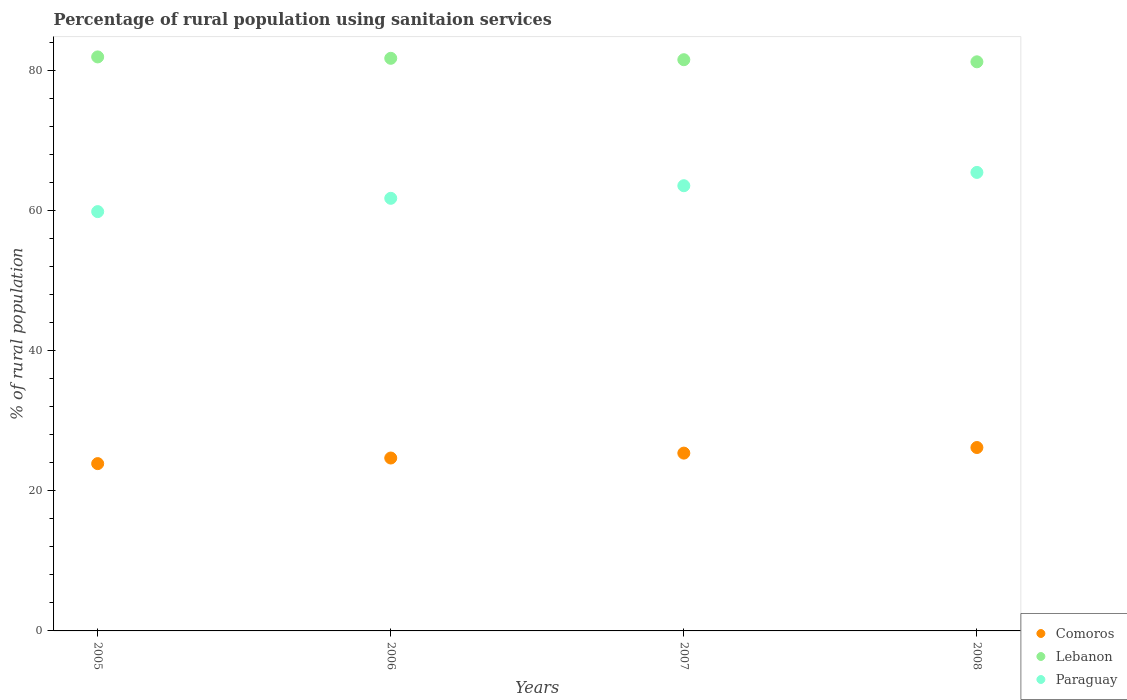How many different coloured dotlines are there?
Provide a succinct answer. 3. What is the percentage of rural population using sanitaion services in Paraguay in 2005?
Your answer should be very brief. 59.9. Across all years, what is the maximum percentage of rural population using sanitaion services in Comoros?
Your answer should be compact. 26.2. Across all years, what is the minimum percentage of rural population using sanitaion services in Comoros?
Provide a succinct answer. 23.9. In which year was the percentage of rural population using sanitaion services in Comoros maximum?
Your answer should be very brief. 2008. What is the total percentage of rural population using sanitaion services in Paraguay in the graph?
Keep it short and to the point. 250.8. What is the difference between the percentage of rural population using sanitaion services in Comoros in 2007 and that in 2008?
Offer a terse response. -0.8. What is the difference between the percentage of rural population using sanitaion services in Lebanon in 2006 and the percentage of rural population using sanitaion services in Paraguay in 2005?
Provide a succinct answer. 21.9. What is the average percentage of rural population using sanitaion services in Lebanon per year?
Provide a short and direct response. 81.67. In the year 2006, what is the difference between the percentage of rural population using sanitaion services in Lebanon and percentage of rural population using sanitaion services in Paraguay?
Your answer should be compact. 20. What is the ratio of the percentage of rural population using sanitaion services in Lebanon in 2006 to that in 2007?
Give a very brief answer. 1. Is the percentage of rural population using sanitaion services in Paraguay in 2006 less than that in 2008?
Offer a very short reply. Yes. What is the difference between the highest and the second highest percentage of rural population using sanitaion services in Lebanon?
Your response must be concise. 0.2. What is the difference between the highest and the lowest percentage of rural population using sanitaion services in Paraguay?
Ensure brevity in your answer.  5.6. In how many years, is the percentage of rural population using sanitaion services in Comoros greater than the average percentage of rural population using sanitaion services in Comoros taken over all years?
Ensure brevity in your answer.  2. Is the percentage of rural population using sanitaion services in Comoros strictly greater than the percentage of rural population using sanitaion services in Lebanon over the years?
Give a very brief answer. No. How many dotlines are there?
Give a very brief answer. 3. What is the difference between two consecutive major ticks on the Y-axis?
Offer a terse response. 20. Are the values on the major ticks of Y-axis written in scientific E-notation?
Offer a terse response. No. Does the graph contain any zero values?
Your response must be concise. No. Does the graph contain grids?
Make the answer very short. No. How are the legend labels stacked?
Your answer should be compact. Vertical. What is the title of the graph?
Ensure brevity in your answer.  Percentage of rural population using sanitaion services. What is the label or title of the X-axis?
Offer a terse response. Years. What is the label or title of the Y-axis?
Your response must be concise. % of rural population. What is the % of rural population in Comoros in 2005?
Your answer should be compact. 23.9. What is the % of rural population in Lebanon in 2005?
Offer a very short reply. 82. What is the % of rural population in Paraguay in 2005?
Provide a succinct answer. 59.9. What is the % of rural population in Comoros in 2006?
Provide a short and direct response. 24.7. What is the % of rural population of Lebanon in 2006?
Offer a very short reply. 81.8. What is the % of rural population of Paraguay in 2006?
Make the answer very short. 61.8. What is the % of rural population of Comoros in 2007?
Make the answer very short. 25.4. What is the % of rural population in Lebanon in 2007?
Your answer should be very brief. 81.6. What is the % of rural population of Paraguay in 2007?
Your answer should be compact. 63.6. What is the % of rural population in Comoros in 2008?
Your answer should be compact. 26.2. What is the % of rural population of Lebanon in 2008?
Offer a terse response. 81.3. What is the % of rural population in Paraguay in 2008?
Give a very brief answer. 65.5. Across all years, what is the maximum % of rural population in Comoros?
Ensure brevity in your answer.  26.2. Across all years, what is the maximum % of rural population of Lebanon?
Make the answer very short. 82. Across all years, what is the maximum % of rural population of Paraguay?
Make the answer very short. 65.5. Across all years, what is the minimum % of rural population of Comoros?
Offer a very short reply. 23.9. Across all years, what is the minimum % of rural population in Lebanon?
Give a very brief answer. 81.3. Across all years, what is the minimum % of rural population of Paraguay?
Offer a very short reply. 59.9. What is the total % of rural population of Comoros in the graph?
Make the answer very short. 100.2. What is the total % of rural population in Lebanon in the graph?
Your answer should be compact. 326.7. What is the total % of rural population in Paraguay in the graph?
Offer a terse response. 250.8. What is the difference between the % of rural population of Lebanon in 2005 and that in 2006?
Offer a terse response. 0.2. What is the difference between the % of rural population in Paraguay in 2005 and that in 2006?
Your answer should be compact. -1.9. What is the difference between the % of rural population in Comoros in 2005 and that in 2007?
Your answer should be very brief. -1.5. What is the difference between the % of rural population of Lebanon in 2005 and that in 2007?
Provide a short and direct response. 0.4. What is the difference between the % of rural population in Paraguay in 2005 and that in 2007?
Provide a short and direct response. -3.7. What is the difference between the % of rural population of Lebanon in 2005 and that in 2008?
Your answer should be compact. 0.7. What is the difference between the % of rural population of Comoros in 2006 and that in 2007?
Your answer should be compact. -0.7. What is the difference between the % of rural population of Comoros in 2006 and that in 2008?
Make the answer very short. -1.5. What is the difference between the % of rural population in Paraguay in 2006 and that in 2008?
Provide a succinct answer. -3.7. What is the difference between the % of rural population in Comoros in 2007 and that in 2008?
Provide a short and direct response. -0.8. What is the difference between the % of rural population in Comoros in 2005 and the % of rural population in Lebanon in 2006?
Offer a very short reply. -57.9. What is the difference between the % of rural population in Comoros in 2005 and the % of rural population in Paraguay in 2006?
Keep it short and to the point. -37.9. What is the difference between the % of rural population of Lebanon in 2005 and the % of rural population of Paraguay in 2006?
Your answer should be compact. 20.2. What is the difference between the % of rural population in Comoros in 2005 and the % of rural population in Lebanon in 2007?
Provide a succinct answer. -57.7. What is the difference between the % of rural population of Comoros in 2005 and the % of rural population of Paraguay in 2007?
Provide a short and direct response. -39.7. What is the difference between the % of rural population in Comoros in 2005 and the % of rural population in Lebanon in 2008?
Your answer should be very brief. -57.4. What is the difference between the % of rural population in Comoros in 2005 and the % of rural population in Paraguay in 2008?
Make the answer very short. -41.6. What is the difference between the % of rural population in Comoros in 2006 and the % of rural population in Lebanon in 2007?
Your response must be concise. -56.9. What is the difference between the % of rural population of Comoros in 2006 and the % of rural population of Paraguay in 2007?
Your answer should be compact. -38.9. What is the difference between the % of rural population in Lebanon in 2006 and the % of rural population in Paraguay in 2007?
Provide a short and direct response. 18.2. What is the difference between the % of rural population in Comoros in 2006 and the % of rural population in Lebanon in 2008?
Make the answer very short. -56.6. What is the difference between the % of rural population in Comoros in 2006 and the % of rural population in Paraguay in 2008?
Ensure brevity in your answer.  -40.8. What is the difference between the % of rural population of Lebanon in 2006 and the % of rural population of Paraguay in 2008?
Your response must be concise. 16.3. What is the difference between the % of rural population in Comoros in 2007 and the % of rural population in Lebanon in 2008?
Provide a short and direct response. -55.9. What is the difference between the % of rural population of Comoros in 2007 and the % of rural population of Paraguay in 2008?
Provide a short and direct response. -40.1. What is the difference between the % of rural population of Lebanon in 2007 and the % of rural population of Paraguay in 2008?
Your answer should be compact. 16.1. What is the average % of rural population of Comoros per year?
Your response must be concise. 25.05. What is the average % of rural population in Lebanon per year?
Offer a terse response. 81.67. What is the average % of rural population in Paraguay per year?
Provide a short and direct response. 62.7. In the year 2005, what is the difference between the % of rural population of Comoros and % of rural population of Lebanon?
Offer a terse response. -58.1. In the year 2005, what is the difference between the % of rural population of Comoros and % of rural population of Paraguay?
Offer a terse response. -36. In the year 2005, what is the difference between the % of rural population of Lebanon and % of rural population of Paraguay?
Your answer should be very brief. 22.1. In the year 2006, what is the difference between the % of rural population in Comoros and % of rural population in Lebanon?
Your answer should be very brief. -57.1. In the year 2006, what is the difference between the % of rural population of Comoros and % of rural population of Paraguay?
Provide a short and direct response. -37.1. In the year 2007, what is the difference between the % of rural population of Comoros and % of rural population of Lebanon?
Offer a very short reply. -56.2. In the year 2007, what is the difference between the % of rural population of Comoros and % of rural population of Paraguay?
Provide a succinct answer. -38.2. In the year 2007, what is the difference between the % of rural population of Lebanon and % of rural population of Paraguay?
Provide a succinct answer. 18. In the year 2008, what is the difference between the % of rural population of Comoros and % of rural population of Lebanon?
Make the answer very short. -55.1. In the year 2008, what is the difference between the % of rural population in Comoros and % of rural population in Paraguay?
Provide a short and direct response. -39.3. In the year 2008, what is the difference between the % of rural population of Lebanon and % of rural population of Paraguay?
Ensure brevity in your answer.  15.8. What is the ratio of the % of rural population in Comoros in 2005 to that in 2006?
Provide a succinct answer. 0.97. What is the ratio of the % of rural population in Lebanon in 2005 to that in 2006?
Your response must be concise. 1. What is the ratio of the % of rural population of Paraguay in 2005 to that in 2006?
Offer a very short reply. 0.97. What is the ratio of the % of rural population of Comoros in 2005 to that in 2007?
Keep it short and to the point. 0.94. What is the ratio of the % of rural population in Paraguay in 2005 to that in 2007?
Offer a terse response. 0.94. What is the ratio of the % of rural population of Comoros in 2005 to that in 2008?
Give a very brief answer. 0.91. What is the ratio of the % of rural population of Lebanon in 2005 to that in 2008?
Keep it short and to the point. 1.01. What is the ratio of the % of rural population in Paraguay in 2005 to that in 2008?
Keep it short and to the point. 0.91. What is the ratio of the % of rural population in Comoros in 2006 to that in 2007?
Offer a very short reply. 0.97. What is the ratio of the % of rural population in Paraguay in 2006 to that in 2007?
Offer a terse response. 0.97. What is the ratio of the % of rural population of Comoros in 2006 to that in 2008?
Make the answer very short. 0.94. What is the ratio of the % of rural population of Paraguay in 2006 to that in 2008?
Your response must be concise. 0.94. What is the ratio of the % of rural population of Comoros in 2007 to that in 2008?
Provide a short and direct response. 0.97. What is the ratio of the % of rural population in Lebanon in 2007 to that in 2008?
Offer a very short reply. 1. What is the ratio of the % of rural population of Paraguay in 2007 to that in 2008?
Keep it short and to the point. 0.97. What is the difference between the highest and the second highest % of rural population in Paraguay?
Make the answer very short. 1.9. What is the difference between the highest and the lowest % of rural population of Comoros?
Ensure brevity in your answer.  2.3. 